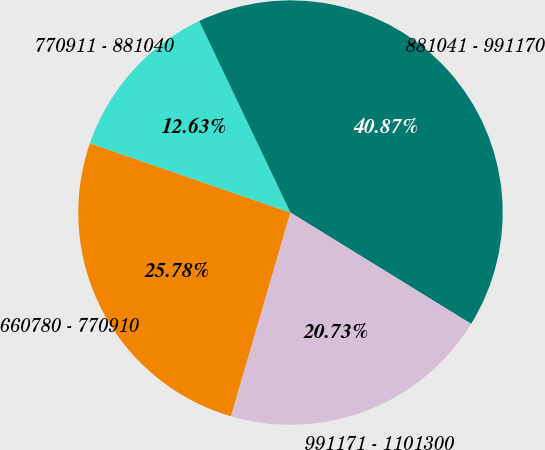Convert chart. <chart><loc_0><loc_0><loc_500><loc_500><pie_chart><fcel>660780 - 770910<fcel>770911 - 881040<fcel>881041 - 991170<fcel>991171 - 1101300<nl><fcel>25.78%<fcel>12.63%<fcel>40.87%<fcel>20.73%<nl></chart> 